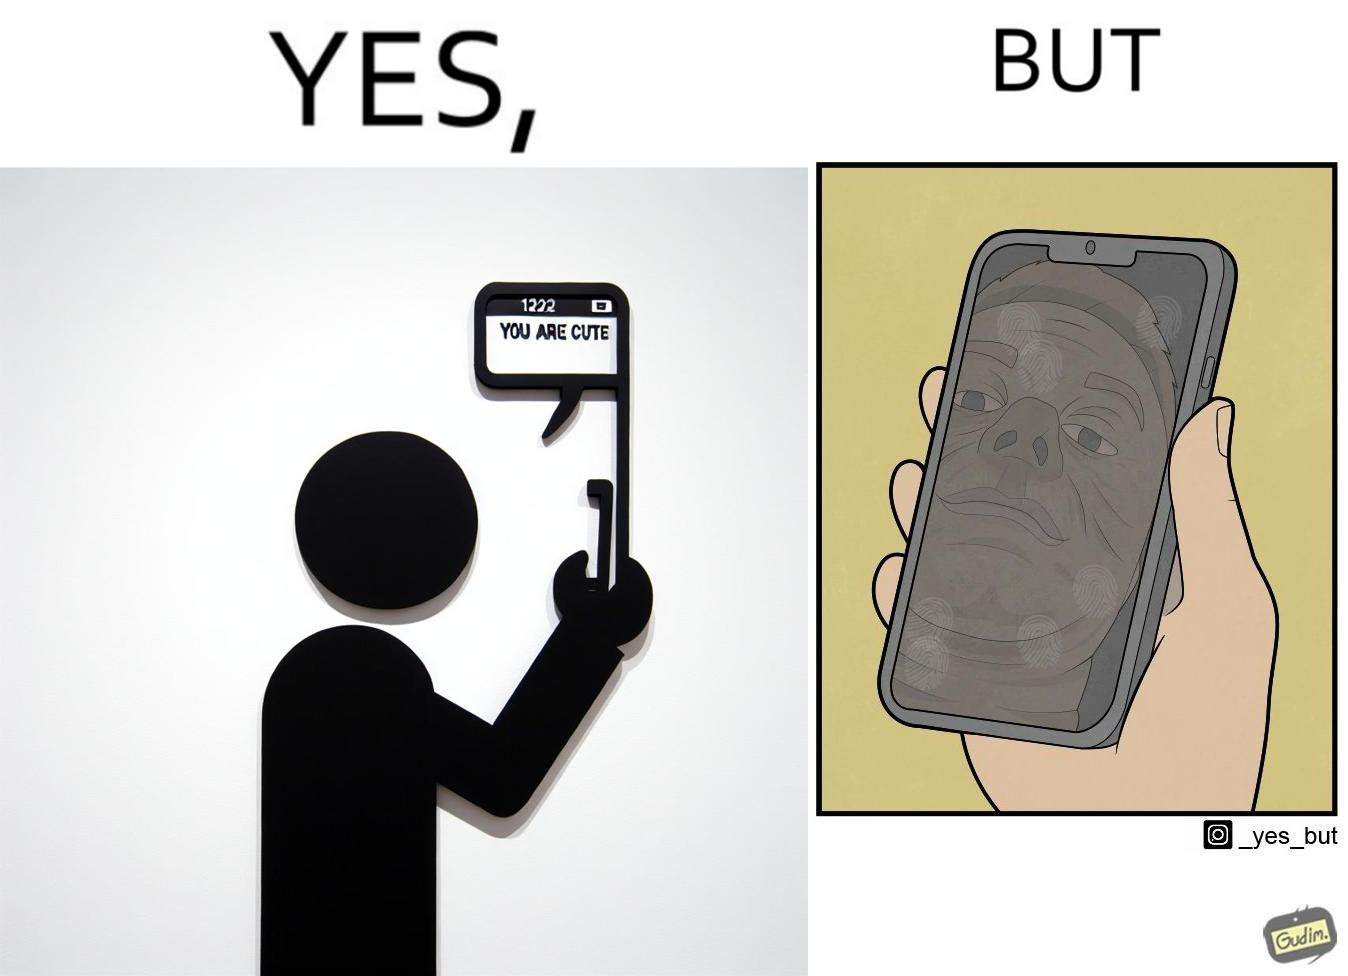Is this image satirical or non-satirical? Yes, this image is satirical. 